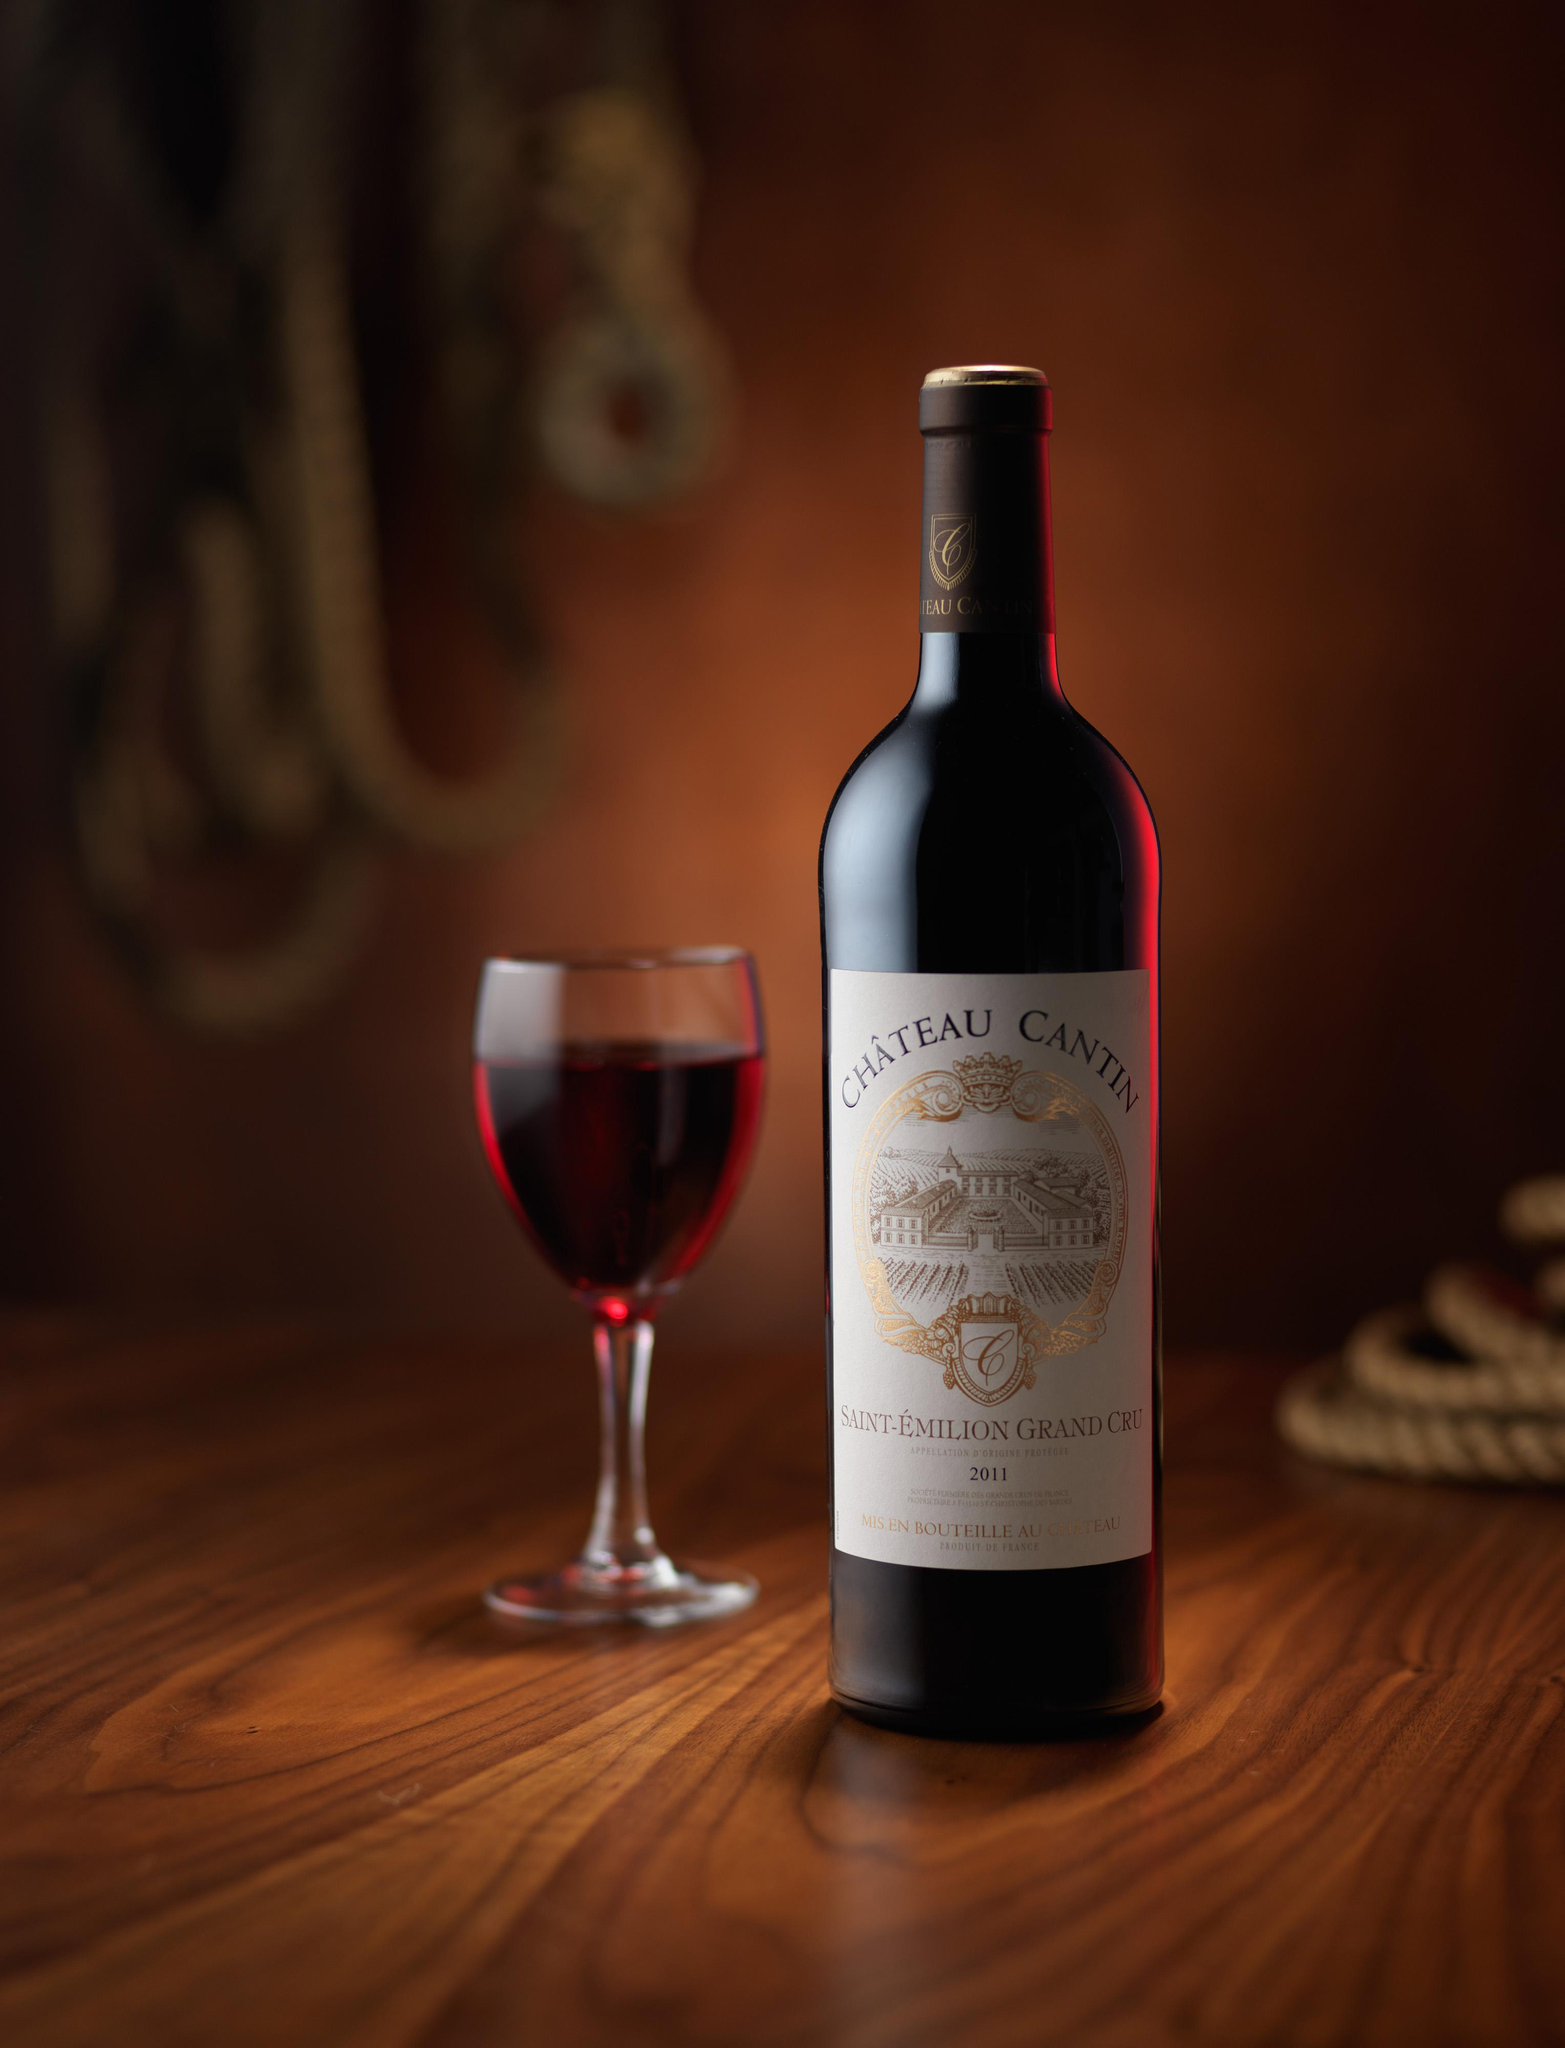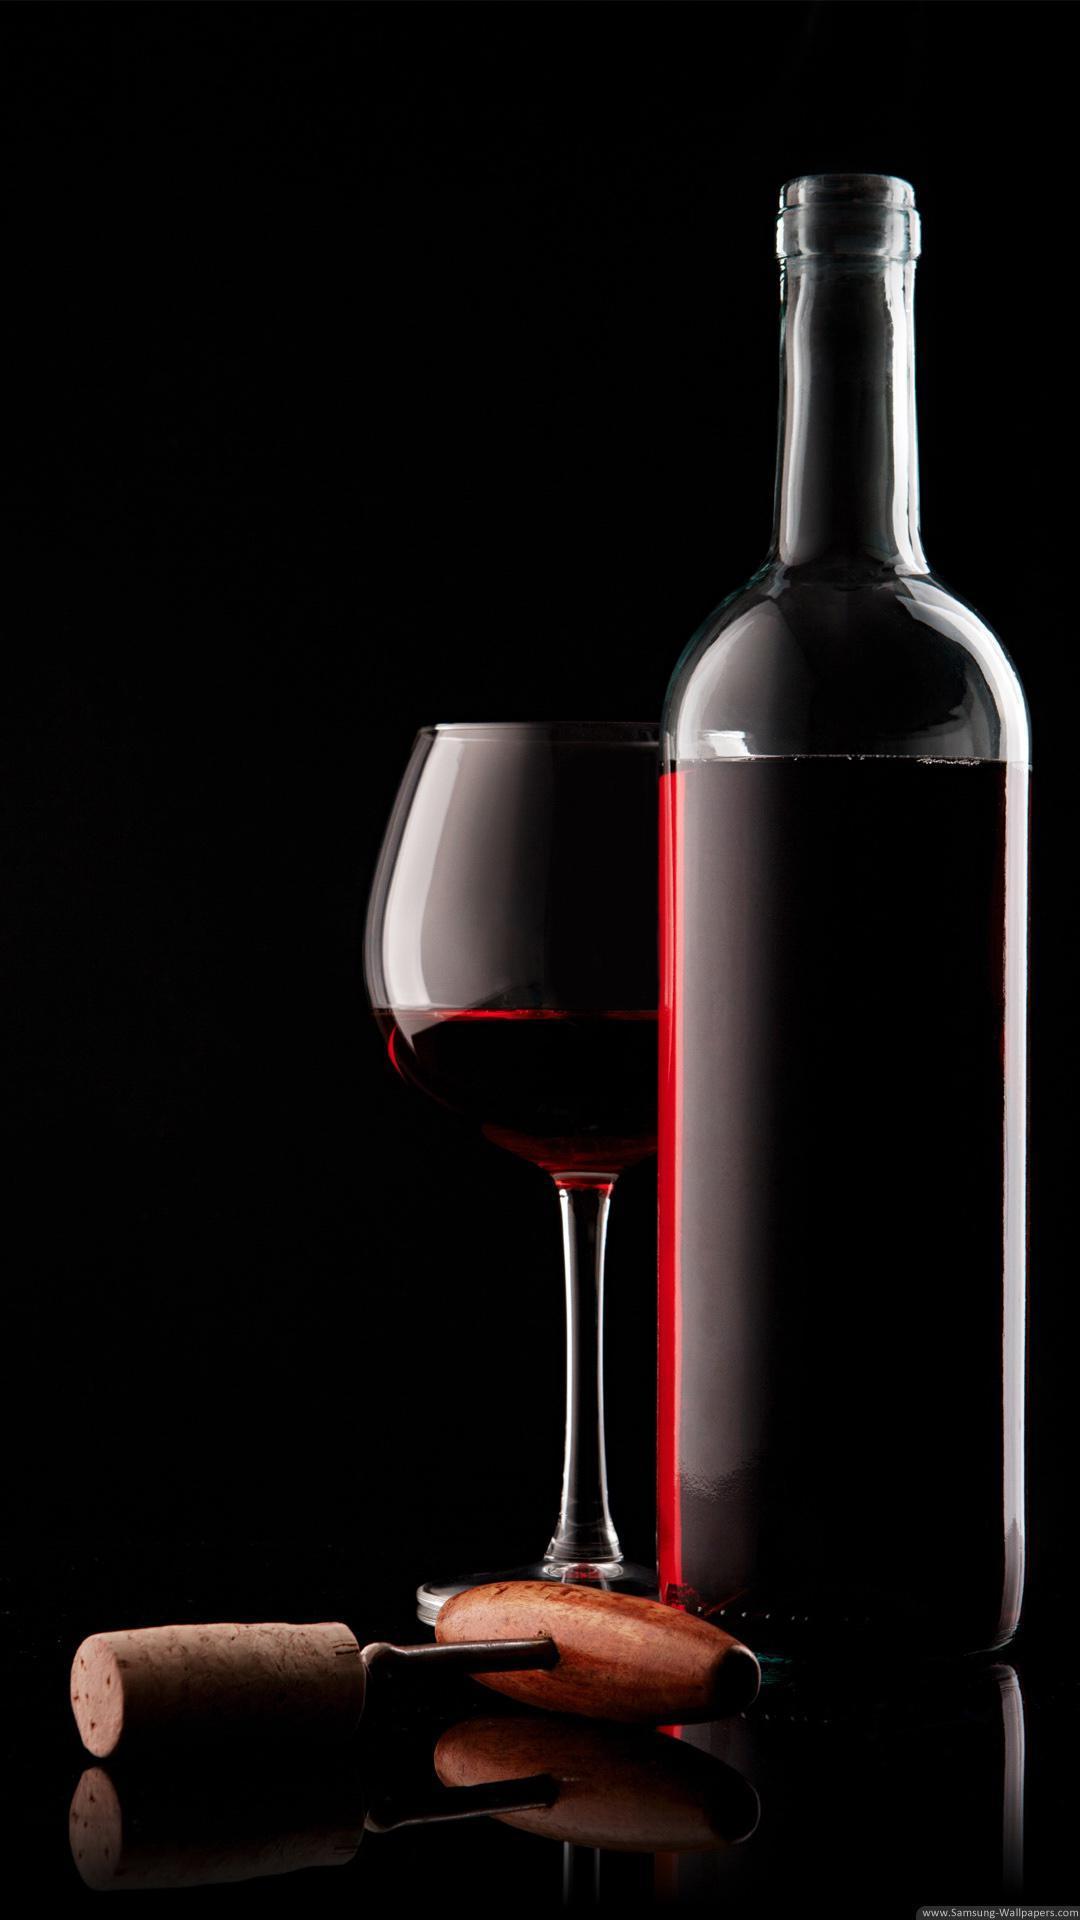The first image is the image on the left, the second image is the image on the right. Evaluate the accuracy of this statement regarding the images: "There are two wineglasses in one of the images.". Is it true? Answer yes or no. No. 